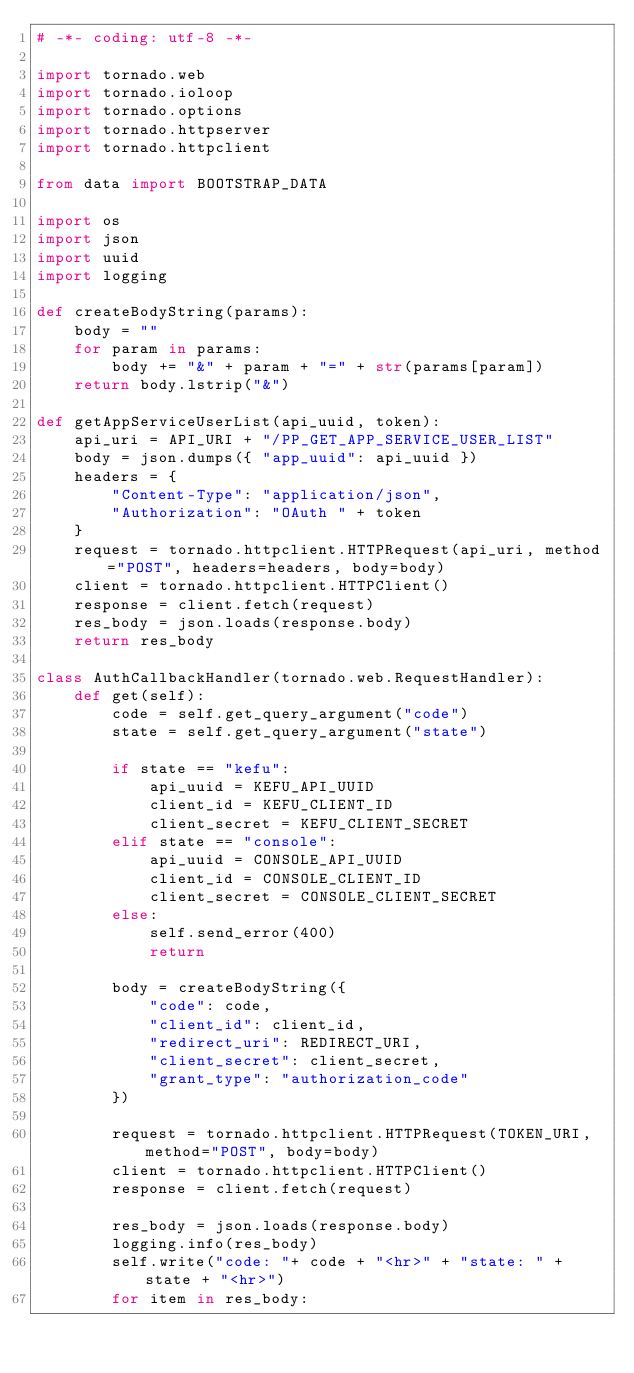<code> <loc_0><loc_0><loc_500><loc_500><_Python_># -*- coding: utf-8 -*-

import tornado.web
import tornado.ioloop
import tornado.options
import tornado.httpserver
import tornado.httpclient

from data import BOOTSTRAP_DATA

import os
import json
import uuid
import logging

def createBodyString(params):
    body = ""
    for param in params:
        body += "&" + param + "=" + str(params[param])
    return body.lstrip("&")

def getAppServiceUserList(api_uuid, token):
    api_uri = API_URI + "/PP_GET_APP_SERVICE_USER_LIST"
    body = json.dumps({ "app_uuid": api_uuid })
    headers = {
        "Content-Type": "application/json",
        "Authorization": "OAuth " + token
    }
    request = tornado.httpclient.HTTPRequest(api_uri, method="POST", headers=headers, body=body)
    client = tornado.httpclient.HTTPClient()
    response = client.fetch(request)
    res_body = json.loads(response.body)
    return res_body

class AuthCallbackHandler(tornado.web.RequestHandler):
    def get(self):
        code = self.get_query_argument("code")
        state = self.get_query_argument("state")

        if state == "kefu":
            api_uuid = KEFU_API_UUID
            client_id = KEFU_CLIENT_ID
            client_secret = KEFU_CLIENT_SECRET
        elif state == "console":
            api_uuid = CONSOLE_API_UUID
            client_id = CONSOLE_CLIENT_ID
            client_secret = CONSOLE_CLIENT_SECRET
        else:
            self.send_error(400)
            return
        
        body = createBodyString({
            "code": code,
            "client_id": client_id,
            "redirect_uri": REDIRECT_URI,
            "client_secret": client_secret,
            "grant_type": "authorization_code"
        })

        request = tornado.httpclient.HTTPRequest(TOKEN_URI, method="POST", body=body)
        client = tornado.httpclient.HTTPClient()
        response = client.fetch(request)

        res_body = json.loads(response.body)
        logging.info(res_body)
        self.write("code: "+ code + "<hr>" + "state: " + state + "<hr>")
        for item in res_body:</code> 